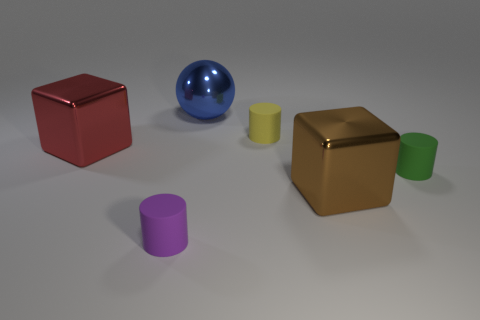Add 4 large red things. How many objects exist? 10 Subtract all blocks. How many objects are left? 4 Subtract all red objects. Subtract all small purple matte objects. How many objects are left? 4 Add 2 yellow rubber cylinders. How many yellow rubber cylinders are left? 3 Add 6 small green matte things. How many small green matte things exist? 7 Subtract 1 yellow cylinders. How many objects are left? 5 